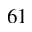Convert formula to latex. <formula><loc_0><loc_0><loc_500><loc_500>^ { 6 } 1</formula> 